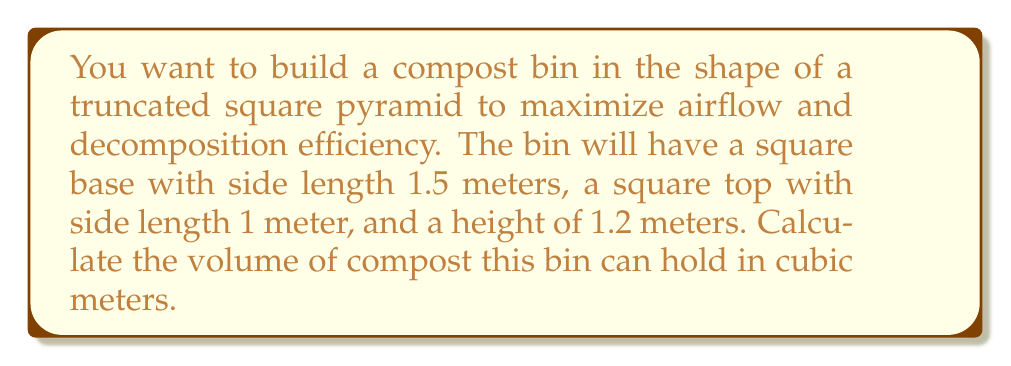Help me with this question. To solve this problem, we'll use the formula for the volume of a truncated pyramid:

$$V = \frac{h}{3}(a^2 + ab + b^2)$$

Where:
$V$ = volume
$h$ = height of the truncated pyramid
$a$ = side length of the larger square (base)
$b$ = side length of the smaller square (top)

Given:
$h = 1.2$ m
$a = 1.5$ m
$b = 1$ m

Let's substitute these values into the formula:

$$V = \frac{1.2}{3}(1.5^2 + 1.5 \times 1 + 1^2)$$

Now, let's calculate step by step:

1) First, calculate the terms inside the parentheses:
   $1.5^2 = 2.25$
   $1.5 \times 1 = 1.5$
   $1^2 = 1$

2) Add these terms:
   $2.25 + 1.5 + 1 = 4.75$

3) Multiply by $\frac{1.2}{3}$:
   $$V = \frac{1.2}{3} \times 4.75 = 0.4 \times 4.75 = 1.9$$

Therefore, the volume of the compost bin is 1.9 cubic meters.
Answer: 1.9 m³ 